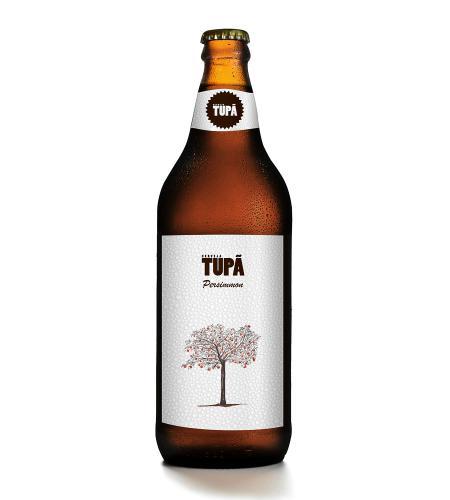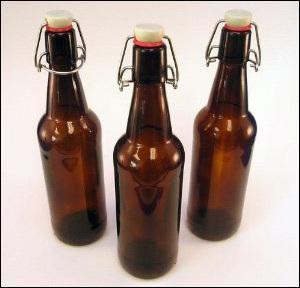The first image is the image on the left, the second image is the image on the right. Considering the images on both sides, is "More bottles are depicted in the right image than the left." valid? Answer yes or no. Yes. 